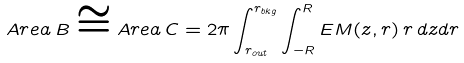Convert formula to latex. <formula><loc_0><loc_0><loc_500><loc_500>A r e a \, B \cong A r e a \, C = 2 \pi \int _ { r _ { o u t } } ^ { r _ { b k g } } \int _ { - R } ^ { R } E M ( z , r ) \, r \, d z d r</formula> 